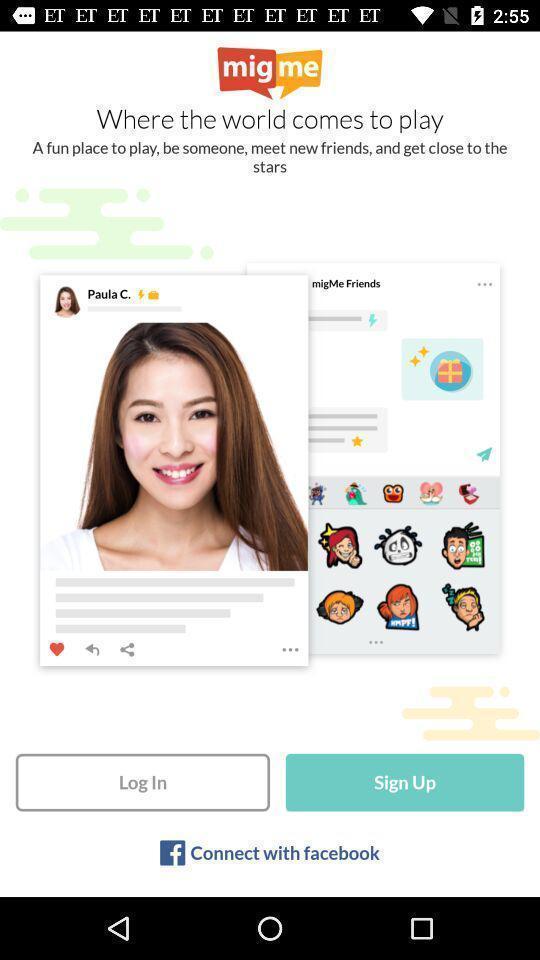Please provide a description for this image. Welcome page for a social app. 